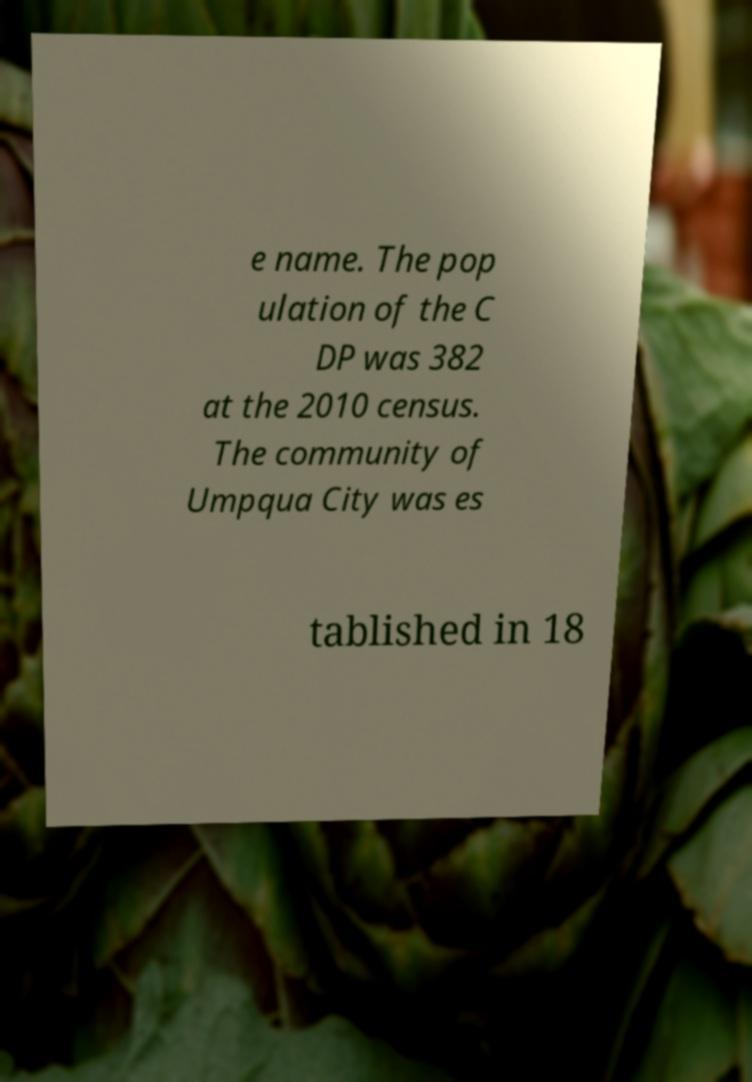Can you accurately transcribe the text from the provided image for me? e name. The pop ulation of the C DP was 382 at the 2010 census. The community of Umpqua City was es tablished in 18 